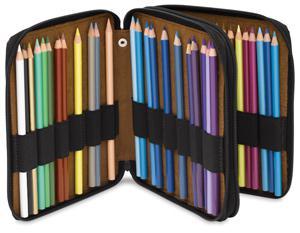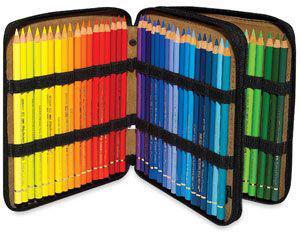The first image is the image on the left, the second image is the image on the right. Examine the images to the left and right. Is the description "All of the pencil cases are standing on their sides." accurate? Answer yes or no. Yes. 